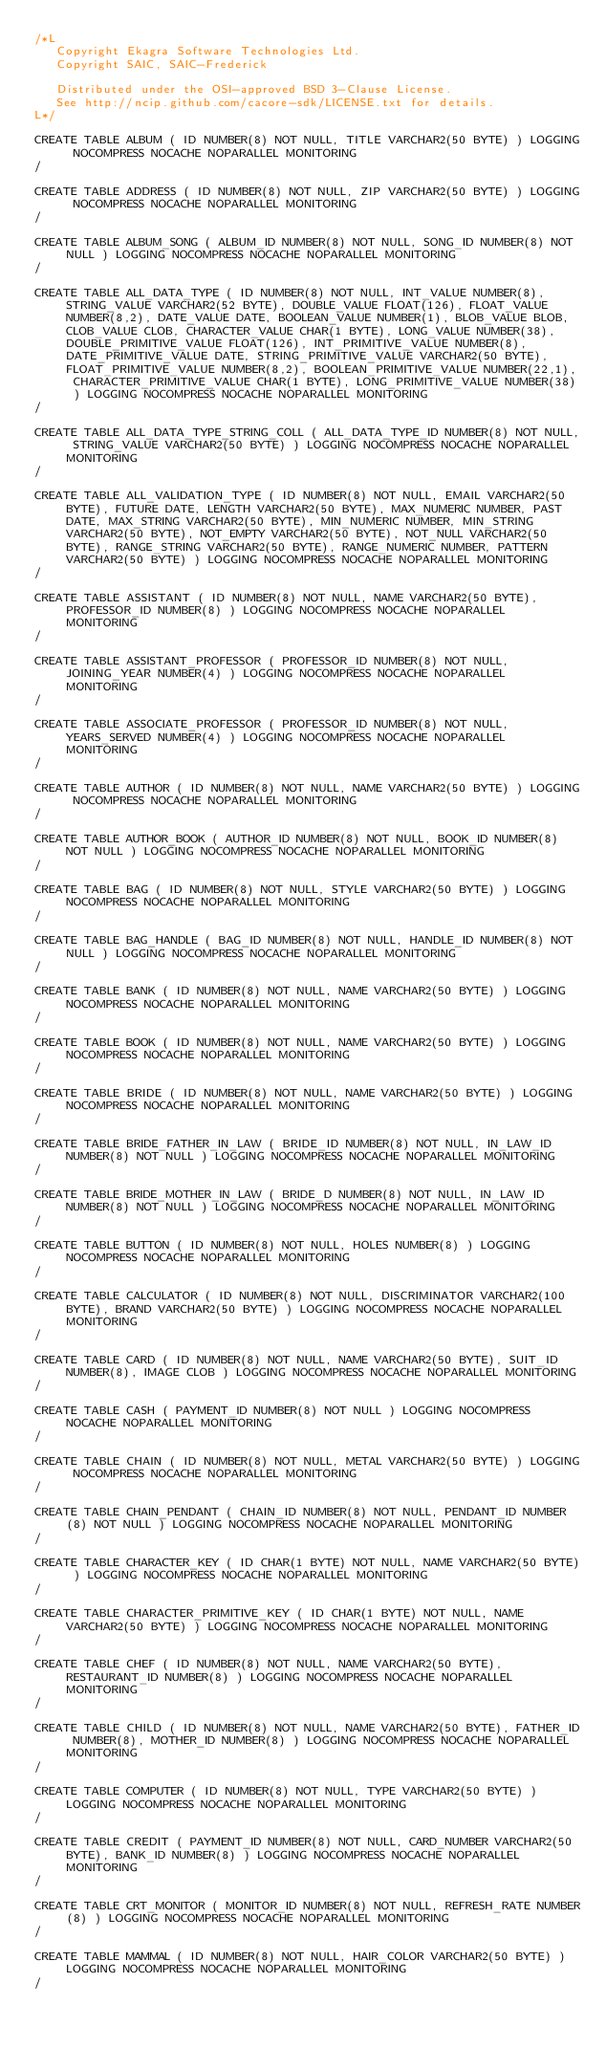Convert code to text. <code><loc_0><loc_0><loc_500><loc_500><_SQL_>/*L
   Copyright Ekagra Software Technologies Ltd.
   Copyright SAIC, SAIC-Frederick

   Distributed under the OSI-approved BSD 3-Clause License.
   See http://ncip.github.com/cacore-sdk/LICENSE.txt for details.
L*/

CREATE TABLE ALBUM ( ID NUMBER(8) NOT NULL, TITLE VARCHAR2(50 BYTE) ) LOGGING NOCOMPRESS NOCACHE NOPARALLEL MONITORING
/

CREATE TABLE ADDRESS ( ID NUMBER(8) NOT NULL, ZIP VARCHAR2(50 BYTE) ) LOGGING NOCOMPRESS NOCACHE NOPARALLEL MONITORING
/

CREATE TABLE ALBUM_SONG ( ALBUM_ID NUMBER(8) NOT NULL, SONG_ID NUMBER(8) NOT NULL ) LOGGING NOCOMPRESS NOCACHE NOPARALLEL MONITORING
/

CREATE TABLE ALL_DATA_TYPE ( ID NUMBER(8) NOT NULL, INT_VALUE NUMBER(8), STRING_VALUE VARCHAR2(52 BYTE), DOUBLE_VALUE FLOAT(126), FLOAT_VALUE NUMBER(8,2), DATE_VALUE DATE, BOOLEAN_VALUE NUMBER(1), BLOB_VALUE BLOB,CLOB_VALUE CLOB, CHARACTER_VALUE CHAR(1 BYTE), LONG_VALUE NUMBER(38), DOUBLE_PRIMITIVE_VALUE FLOAT(126), INT_PRIMITIVE_VALUE NUMBER(8), DATE_PRIMITIVE_VALUE DATE, STRING_PRIMITIVE_VALUE VARCHAR2(50 BYTE), FLOAT_PRIMITIVE_VALUE NUMBER(8,2), BOOLEAN_PRIMITIVE_VALUE NUMBER(22,1), CHARACTER_PRIMITIVE_VALUE CHAR(1 BYTE), LONG_PRIMITIVE_VALUE NUMBER(38) ) LOGGING NOCOMPRESS NOCACHE NOPARALLEL MONITORING
/

CREATE TABLE ALL_DATA_TYPE_STRING_COLL ( ALL_DATA_TYPE_ID NUMBER(8) NOT NULL, STRING_VALUE VARCHAR2(50 BYTE) ) LOGGING NOCOMPRESS NOCACHE NOPARALLEL MONITORING
/

CREATE TABLE ALL_VALIDATION_TYPE ( ID NUMBER(8) NOT NULL, EMAIL VARCHAR2(50 BYTE), FUTURE DATE, LENGTH VARCHAR2(50 BYTE), MAX_NUMERIC NUMBER, PAST DATE, MAX_STRING VARCHAR2(50 BYTE), MIN_NUMERIC NUMBER, MIN_STRING VARCHAR2(50 BYTE), NOT_EMPTY VARCHAR2(50 BYTE), NOT_NULL VARCHAR2(50 BYTE), RANGE_STRING VARCHAR2(50 BYTE), RANGE_NUMERIC NUMBER, PATTERN VARCHAR2(50 BYTE) ) LOGGING NOCOMPRESS NOCACHE NOPARALLEL MONITORING
/

CREATE TABLE ASSISTANT ( ID NUMBER(8) NOT NULL, NAME VARCHAR2(50 BYTE), PROFESSOR_ID NUMBER(8) ) LOGGING NOCOMPRESS NOCACHE NOPARALLEL MONITORING
/

CREATE TABLE ASSISTANT_PROFESSOR ( PROFESSOR_ID NUMBER(8) NOT NULL, JOINING_YEAR NUMBER(4) ) LOGGING NOCOMPRESS NOCACHE NOPARALLEL MONITORING
/

CREATE TABLE ASSOCIATE_PROFESSOR ( PROFESSOR_ID NUMBER(8) NOT NULL, YEARS_SERVED NUMBER(4) ) LOGGING NOCOMPRESS NOCACHE NOPARALLEL MONITORING
/

CREATE TABLE AUTHOR ( ID NUMBER(8) NOT NULL, NAME VARCHAR2(50 BYTE) ) LOGGING NOCOMPRESS NOCACHE NOPARALLEL MONITORING
/

CREATE TABLE AUTHOR_BOOK ( AUTHOR_ID NUMBER(8) NOT NULL, BOOK_ID NUMBER(8) NOT NULL ) LOGGING NOCOMPRESS NOCACHE NOPARALLEL MONITORING
/

CREATE TABLE BAG ( ID NUMBER(8) NOT NULL, STYLE VARCHAR2(50 BYTE) ) LOGGING NOCOMPRESS NOCACHE NOPARALLEL MONITORING
/

CREATE TABLE BAG_HANDLE ( BAG_ID NUMBER(8) NOT NULL, HANDLE_ID NUMBER(8) NOT NULL ) LOGGING NOCOMPRESS NOCACHE NOPARALLEL MONITORING
/

CREATE TABLE BANK ( ID NUMBER(8) NOT NULL, NAME VARCHAR2(50 BYTE) ) LOGGING NOCOMPRESS NOCACHE NOPARALLEL MONITORING
/

CREATE TABLE BOOK ( ID NUMBER(8) NOT NULL, NAME VARCHAR2(50 BYTE) ) LOGGING NOCOMPRESS NOCACHE NOPARALLEL MONITORING
/

CREATE TABLE BRIDE ( ID NUMBER(8) NOT NULL, NAME VARCHAR2(50 BYTE) ) LOGGING NOCOMPRESS NOCACHE NOPARALLEL MONITORING
/

CREATE TABLE BRIDE_FATHER_IN_LAW ( BRIDE_ID NUMBER(8) NOT NULL, IN_LAW_ID NUMBER(8) NOT NULL ) LOGGING NOCOMPRESS NOCACHE NOPARALLEL MONITORING
/

CREATE TABLE BRIDE_MOTHER_IN_LAW ( BRIDE_D NUMBER(8) NOT NULL, IN_LAW_ID NUMBER(8) NOT NULL ) LOGGING NOCOMPRESS NOCACHE NOPARALLEL MONITORING
/

CREATE TABLE BUTTON ( ID NUMBER(8) NOT NULL, HOLES NUMBER(8) ) LOGGING NOCOMPRESS NOCACHE NOPARALLEL MONITORING
/

CREATE TABLE CALCULATOR ( ID NUMBER(8) NOT NULL, DISCRIMINATOR VARCHAR2(100 BYTE), BRAND VARCHAR2(50 BYTE) ) LOGGING NOCOMPRESS NOCACHE NOPARALLEL MONITORING
/

CREATE TABLE CARD ( ID NUMBER(8) NOT NULL, NAME VARCHAR2(50 BYTE), SUIT_ID NUMBER(8), IMAGE CLOB ) LOGGING NOCOMPRESS NOCACHE NOPARALLEL MONITORING
/

CREATE TABLE CASH ( PAYMENT_ID NUMBER(8) NOT NULL ) LOGGING NOCOMPRESS NOCACHE NOPARALLEL MONITORING
/

CREATE TABLE CHAIN ( ID NUMBER(8) NOT NULL, METAL VARCHAR2(50 BYTE) ) LOGGING NOCOMPRESS NOCACHE NOPARALLEL MONITORING
/

CREATE TABLE CHAIN_PENDANT ( CHAIN_ID NUMBER(8) NOT NULL, PENDANT_ID NUMBER(8) NOT NULL ) LOGGING NOCOMPRESS NOCACHE NOPARALLEL MONITORING
/

CREATE TABLE CHARACTER_KEY ( ID CHAR(1 BYTE) NOT NULL, NAME VARCHAR2(50 BYTE) ) LOGGING NOCOMPRESS NOCACHE NOPARALLEL MONITORING
/

CREATE TABLE CHARACTER_PRIMITIVE_KEY ( ID CHAR(1 BYTE) NOT NULL, NAME VARCHAR2(50 BYTE) ) LOGGING NOCOMPRESS NOCACHE NOPARALLEL MONITORING
/

CREATE TABLE CHEF ( ID NUMBER(8) NOT NULL, NAME VARCHAR2(50 BYTE), RESTAURANT_ID NUMBER(8) ) LOGGING NOCOMPRESS NOCACHE NOPARALLEL MONITORING
/

CREATE TABLE CHILD ( ID NUMBER(8) NOT NULL, NAME VARCHAR2(50 BYTE), FATHER_ID NUMBER(8), MOTHER_ID NUMBER(8) ) LOGGING NOCOMPRESS NOCACHE NOPARALLEL MONITORING
/

CREATE TABLE COMPUTER ( ID NUMBER(8) NOT NULL, TYPE VARCHAR2(50 BYTE) ) LOGGING NOCOMPRESS NOCACHE NOPARALLEL MONITORING
/

CREATE TABLE CREDIT ( PAYMENT_ID NUMBER(8) NOT NULL, CARD_NUMBER VARCHAR2(50 BYTE), BANK_ID NUMBER(8) ) LOGGING NOCOMPRESS NOCACHE NOPARALLEL MONITORING
/

CREATE TABLE CRT_MONITOR ( MONITOR_ID NUMBER(8) NOT NULL, REFRESH_RATE NUMBER(8) ) LOGGING NOCOMPRESS NOCACHE NOPARALLEL MONITORING
/

CREATE TABLE MAMMAL ( ID NUMBER(8) NOT NULL, HAIR_COLOR VARCHAR2(50 BYTE) ) LOGGING NOCOMPRESS NOCACHE NOPARALLEL MONITORING
/

</code> 